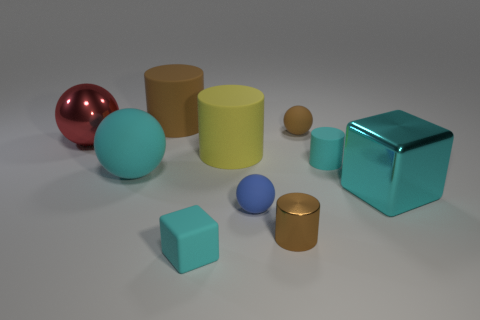Subtract 1 cylinders. How many cylinders are left? 3 Subtract all cylinders. How many objects are left? 6 Subtract all small yellow things. Subtract all balls. How many objects are left? 6 Add 7 blue matte things. How many blue matte things are left? 8 Add 2 blocks. How many blocks exist? 4 Subtract 0 yellow cubes. How many objects are left? 10 